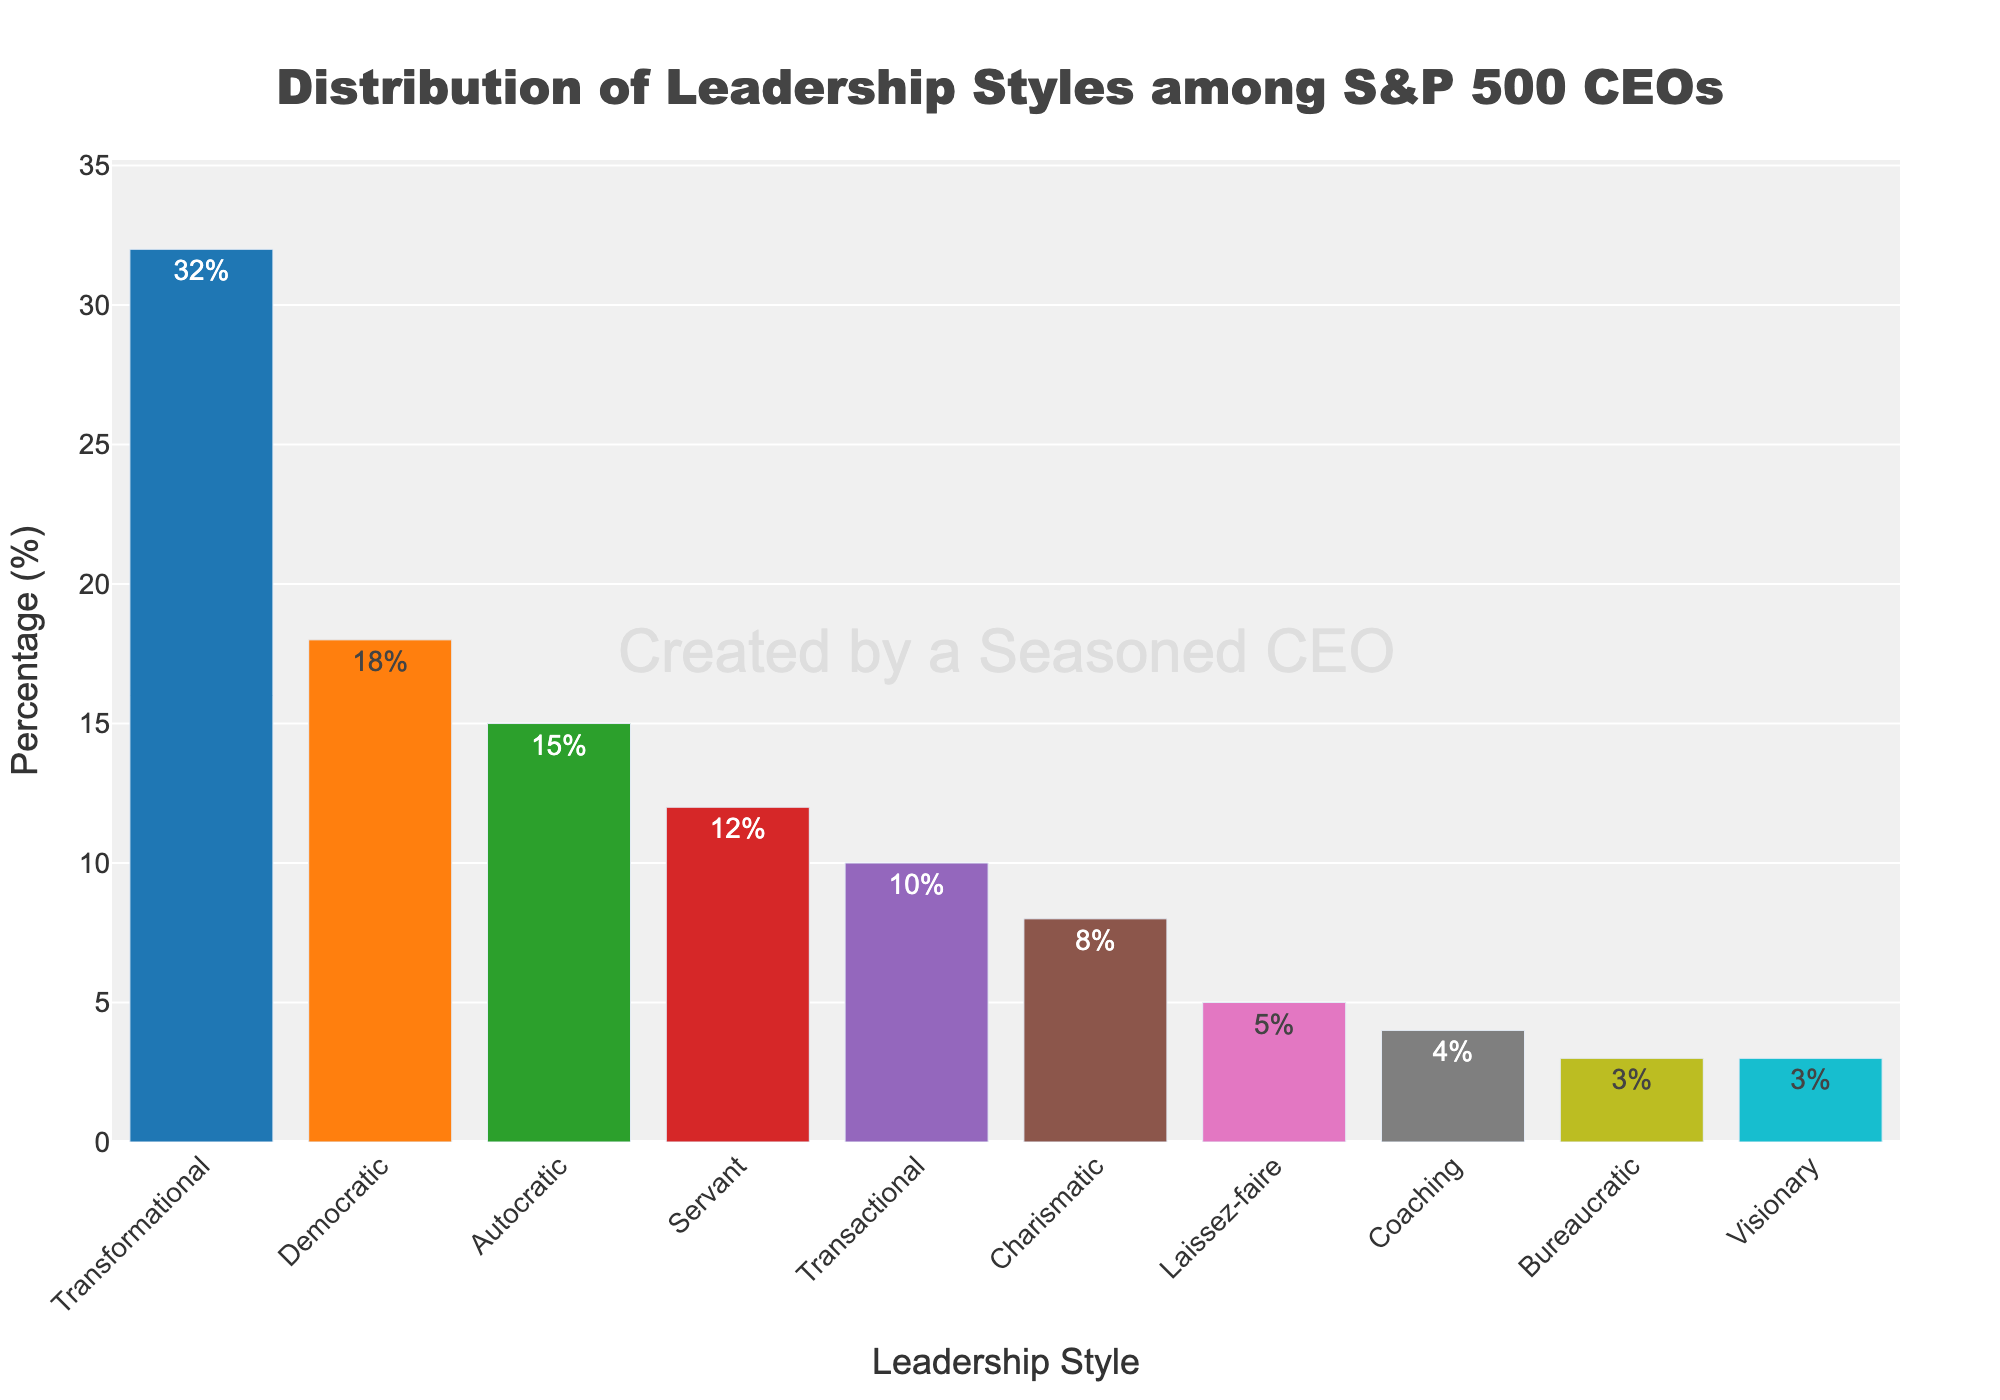What leadership style has the highest percentage among S&P 500 CEOs? The bar representing Transformational Leadership Style is the tallest, indicating it has the highest percentage.
Answer: Transformational How many leadership styles have a percentage of 10% or higher? Reviewing the bars shows that Transformational, Democratic, Autocratic, and Servant leadership styles all have percentages equal to or above 10%.
Answer: 4 Which leadership style has the smallest percentage, and what is it? The bar labeled Bureaucratic and Visionary are the shortest, each reaching 3%.
Answer: Bureaucratic and Visionary, 3% What is the combined percentage of Transformational and Democratic leadership styles? Adding the percentages of Transformational (32%) and Democratic (18%) gives 32 + 18 = 50%.
Answer: 50% Compare the percentage of Transactional and Charismatic leadership styles. Which is greater and by how much? The bar for Transactional reaches 10%, while Charismatic reaches 8%. The difference is 10 - 8 = 2%.
Answer: Transactional by 2% How does the percentage of the Laissez-faire leadership style compare to the Coaching leadership style? The Laissez-faire leadership has a bar reaching 5%, whereas the Coaching leadership reaches 4%.
Answer: Laissez-faire is greater Which leadership styles combined account for less than 10% in total? Adding the percentages of Coaching (4%), Bureaucratic (3%), and Visionary (3%) gives 4 + 3 + 3 = 10%. None of these groups individually account for 10% or more.
Answer: Coaching, Bureaucratic, Visionary What is the total percentage of all leadership styles combined? Summing percentages of all leadership styles: 32 + 18 + 15 + 12 + 10 + 8 + 5 + 4 + 3 + 3 = 110%.
Answer: 110% What percentage comprises the top three leadership styles? Adding percentages of Transformational (32%), Democratic (18%), and Autocratic (15%) gives 32 + 18 + 15 = 65%.
Answer: 65% What do the colors of the bars represent? The bars are colored differently for visual distinction between categories; they do not represent any specific data attribute beyond categorization.
Answer: Distinct categories 